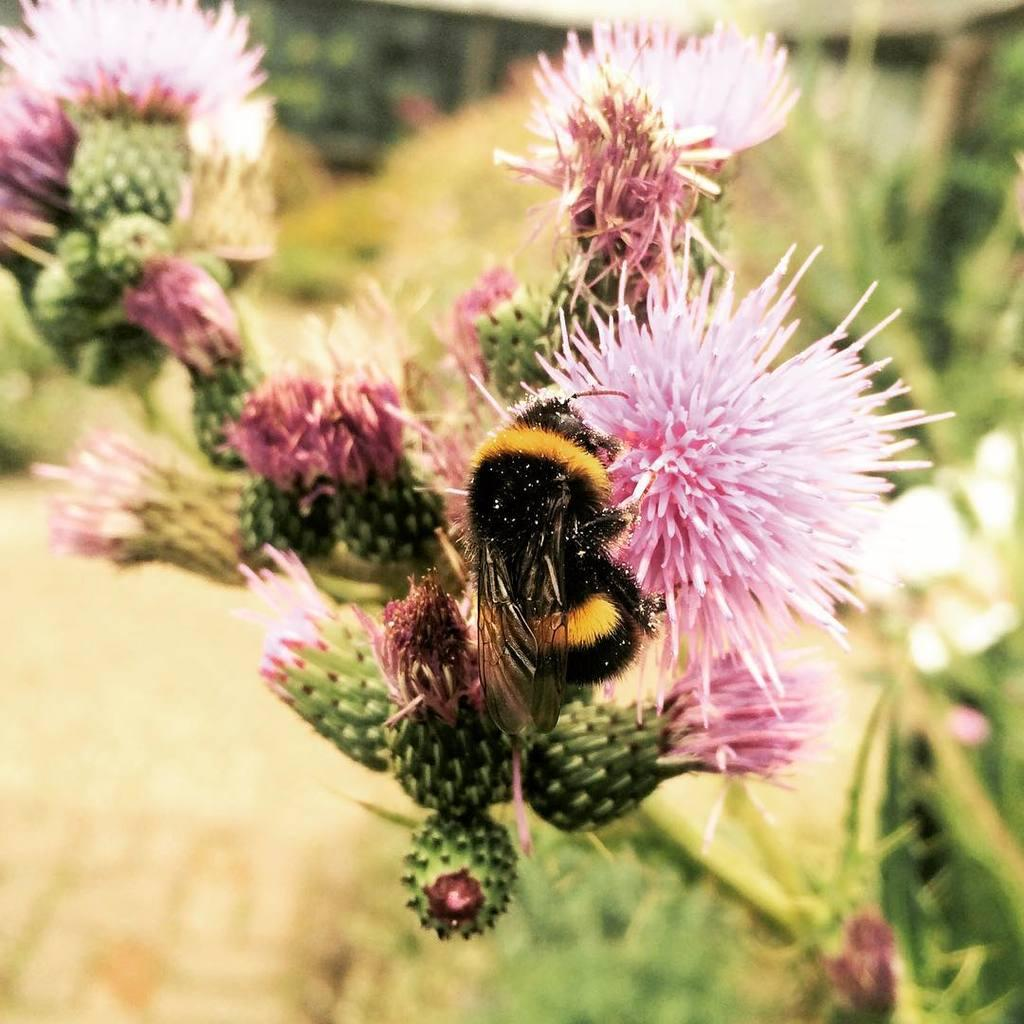What type of plant is visible in the image? There is a plant with flowers in the image. What stage of growth are the flowers in? The plant has buds, indicating that some flowers are still in the process of blooming. Can you describe any living organisms interacting with the plant? Yes, there is an insect on one of the flowers. How would you describe the background of the image? The background of the image is blurred. What type of comb is being used to groom the quartz in the image? There is no comb or quartz present in the image; it features a plant with flowers and an insect. 